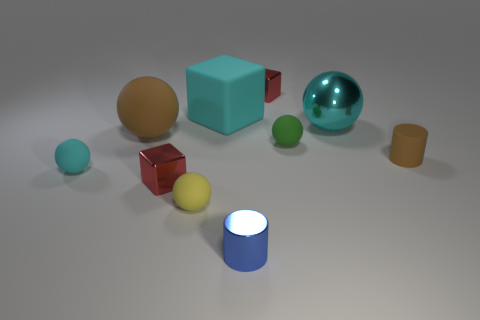Subtract all large cyan rubber blocks. How many blocks are left? 2 Subtract 5 spheres. How many spheres are left? 0 Subtract all red blocks. How many blocks are left? 1 Subtract 1 green spheres. How many objects are left? 9 Subtract all cylinders. How many objects are left? 8 Subtract all gray cylinders. Subtract all green blocks. How many cylinders are left? 2 Subtract all cyan balls. How many blue cylinders are left? 1 Subtract all small metal blocks. Subtract all green spheres. How many objects are left? 7 Add 3 cyan metallic balls. How many cyan metallic balls are left? 4 Add 7 big green metallic cylinders. How many big green metallic cylinders exist? 7 